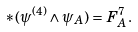<formula> <loc_0><loc_0><loc_500><loc_500>\ast ( \psi ^ { ( 4 ) } \wedge \psi _ { A } ) = F _ { A } ^ { 7 } .</formula> 